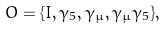<formula> <loc_0><loc_0><loc_500><loc_500>O = \{ I , \gamma _ { 5 } , \gamma _ { \mu } , \gamma _ { \mu } \gamma _ { 5 } \} ,</formula> 